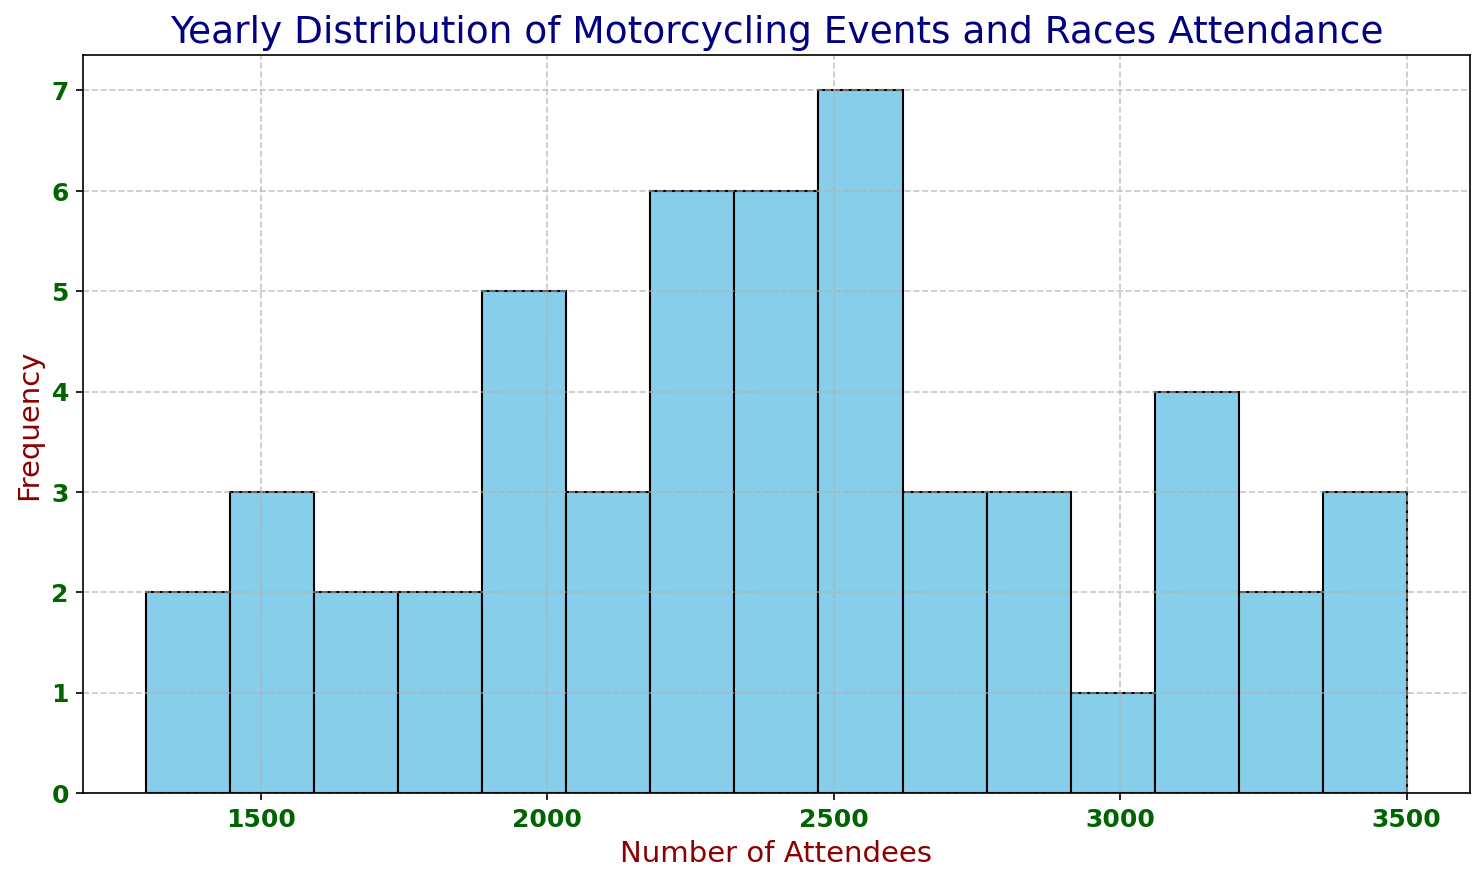What is the most common range of attendees in the events? The histogram bars represent the frequency of the number of attendees. By observing the histogram, identify the bar with the highest frequency, which corresponds to the most common range of attendees.
Answer: 2400-2600 How many events had between 1400 and 1600 attendees? Locate the bars in the histogram that cover the range 1400 to 1600 and read the height of these bars to determine how many events fall within this range.
Answer: 6 Which range has a higher frequency of events: 2000-2200 or 3000-3200? Compare the heights of the bars representing the ranges 2000-2200 and 3000-3200. The tallest bar indicates a higher frequency within that range.
Answer: 2000-2200 What is the range with the lowest frequency of attendees? Finding the lowest bar in the histogram will point to the range with the lowest frequency of attendees.
Answer: 1300-1400 Are there more events with attendees less than 2000 or more than 3000? Sum the frequencies of all bars representing less than 2000 and compare it to the sum of all bars representing more than 3000.
Answer: Less than 2000 What is the median range of attendees? Since this histogram represents a distribution of data, find the middle range after counting the total number of event entries and summing up frequencies until reaching the median position.
Answer: 2300-2500 What can be inferred about events from the year 2020 based on this histogram? Events from 2020 had significantly fewer attendees, visible by multiple low bars concentrated between 1300 and 1600 attendees in the histogram.
Answer: Low attendance Which year likely had the highest average attendance based on the histogram? Identify the range of events with larger attendees across multiple years visible in higher frequency bars; compare these ranges visually.
Answer: 2022 